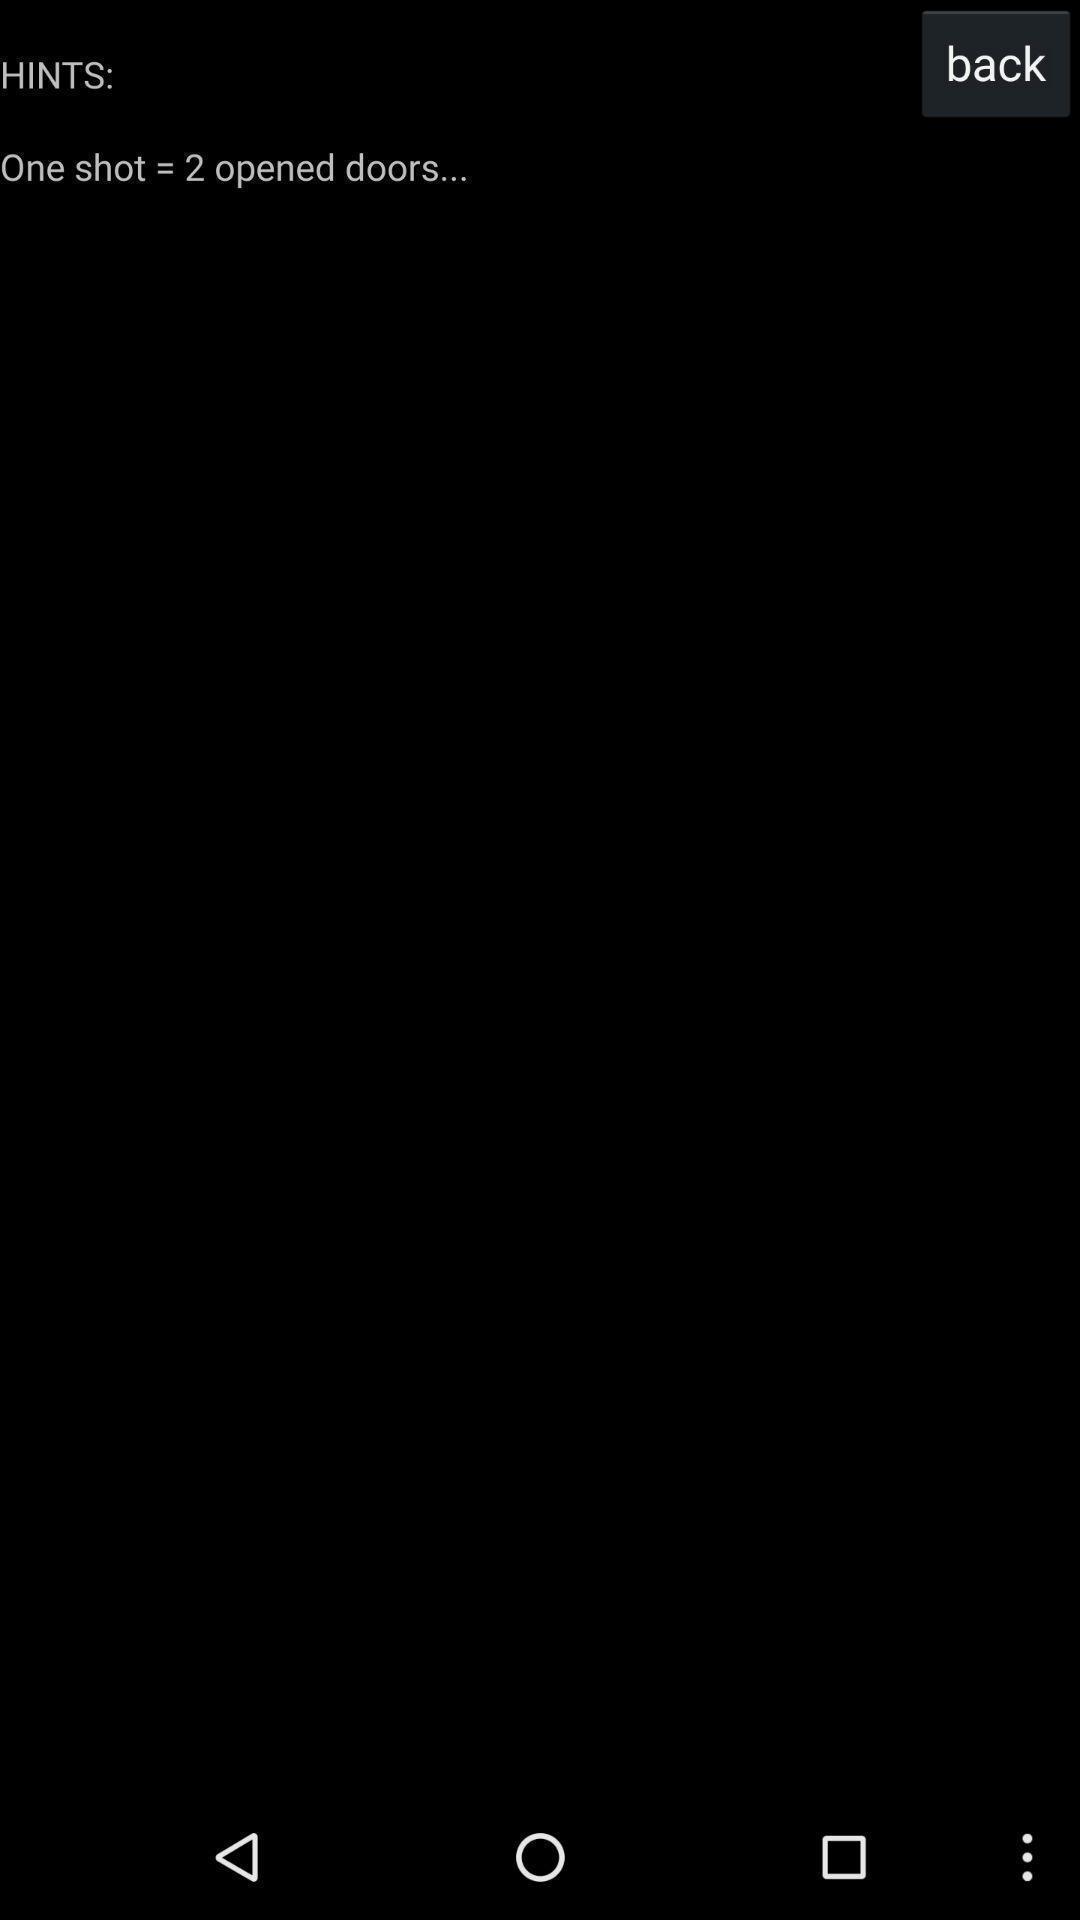Summarize the information in this screenshot. Page showing back option on a blank screen. 